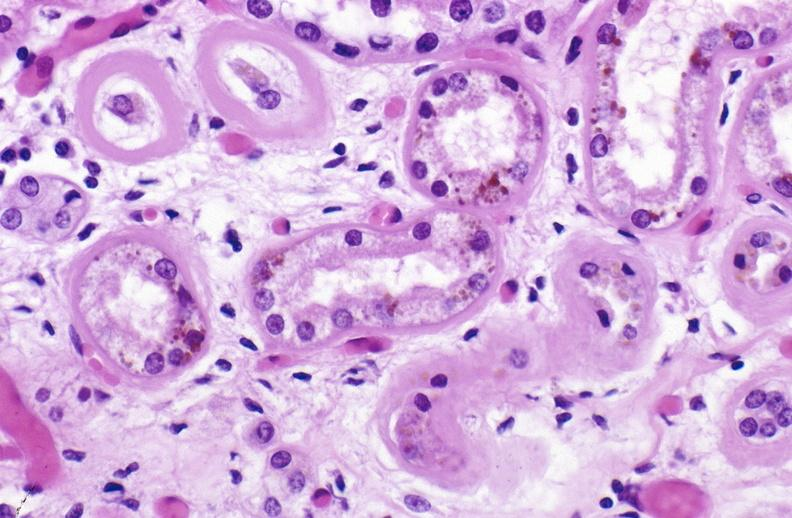does this image show atn and bile pigment?
Answer the question using a single word or phrase. Yes 